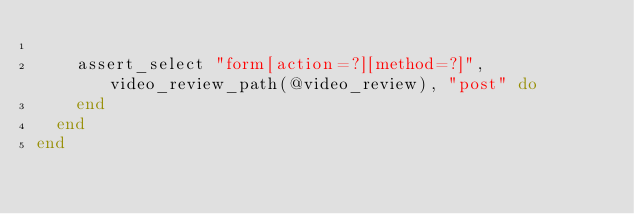Convert code to text. <code><loc_0><loc_0><loc_500><loc_500><_Ruby_>
    assert_select "form[action=?][method=?]", video_review_path(@video_review), "post" do
    end
  end
end
</code> 